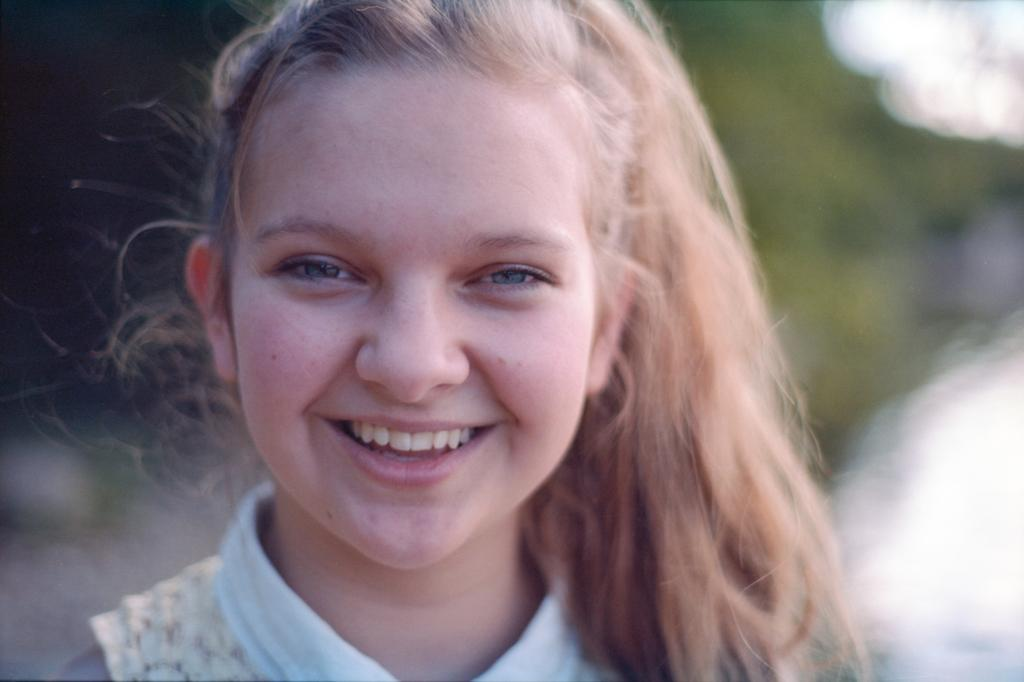Who is the main subject in the image? There is a girl in the image. What expression does the girl have? The girl is smiling. Can you describe the background of the image? The background of the image is blurred. What type of music is the band playing in the background of the image? There is no band present in the image, so it is not possible to determine what type of music they might be playing. 